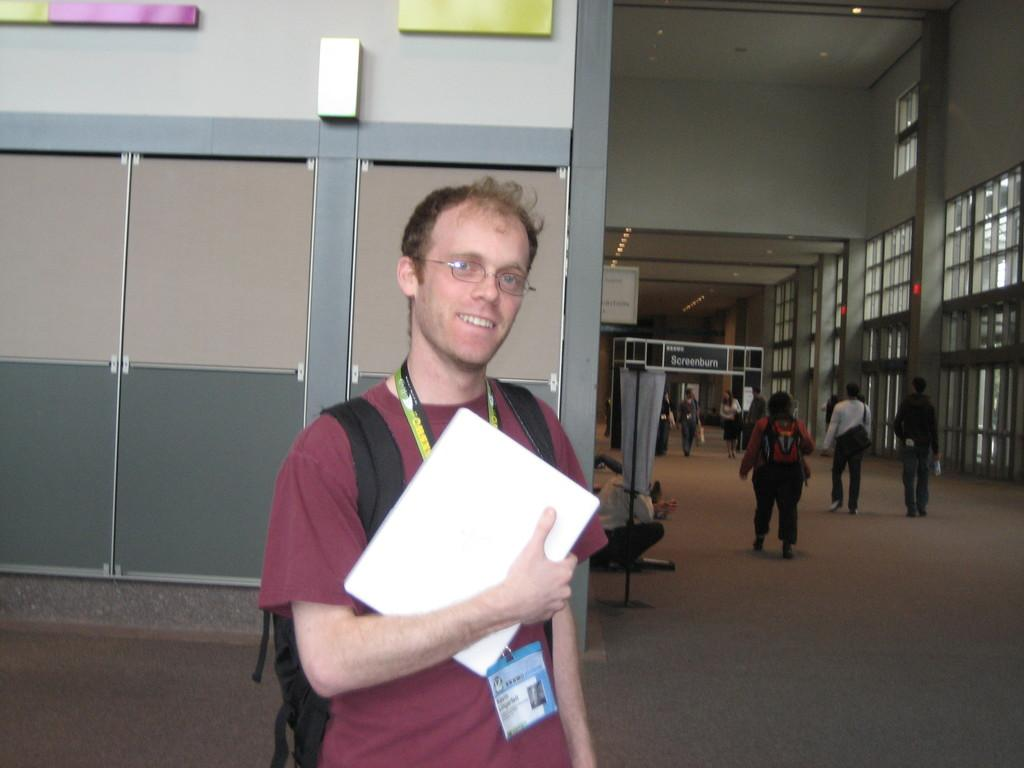What is the main subject of the image? There is a man in the image. What is the man wearing? The man is wearing a t-shirt. What items does the man have with him? The man has a bag and a book. What can be observed about the surroundings in the image? There are many persons walking on the floor, and there are windows visible in the image. How does the man stitch the book in the image? There is no indication in the image that the man is stitching the book. 